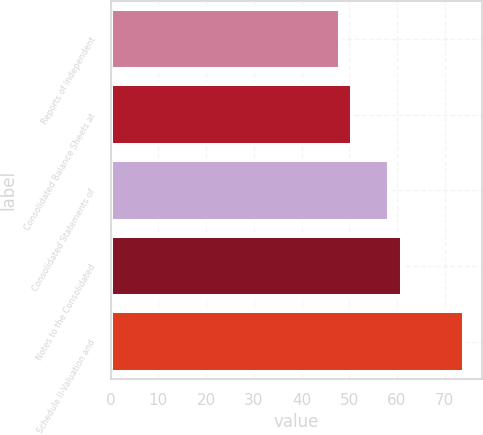<chart> <loc_0><loc_0><loc_500><loc_500><bar_chart><fcel>Reports of Independent<fcel>Consolidated Balance Sheets at<fcel>Consolidated Statements of<fcel>Notes to the Consolidated<fcel>Schedule II-Valuation and<nl><fcel>48<fcel>50.6<fcel>58.4<fcel>61<fcel>74<nl></chart> 